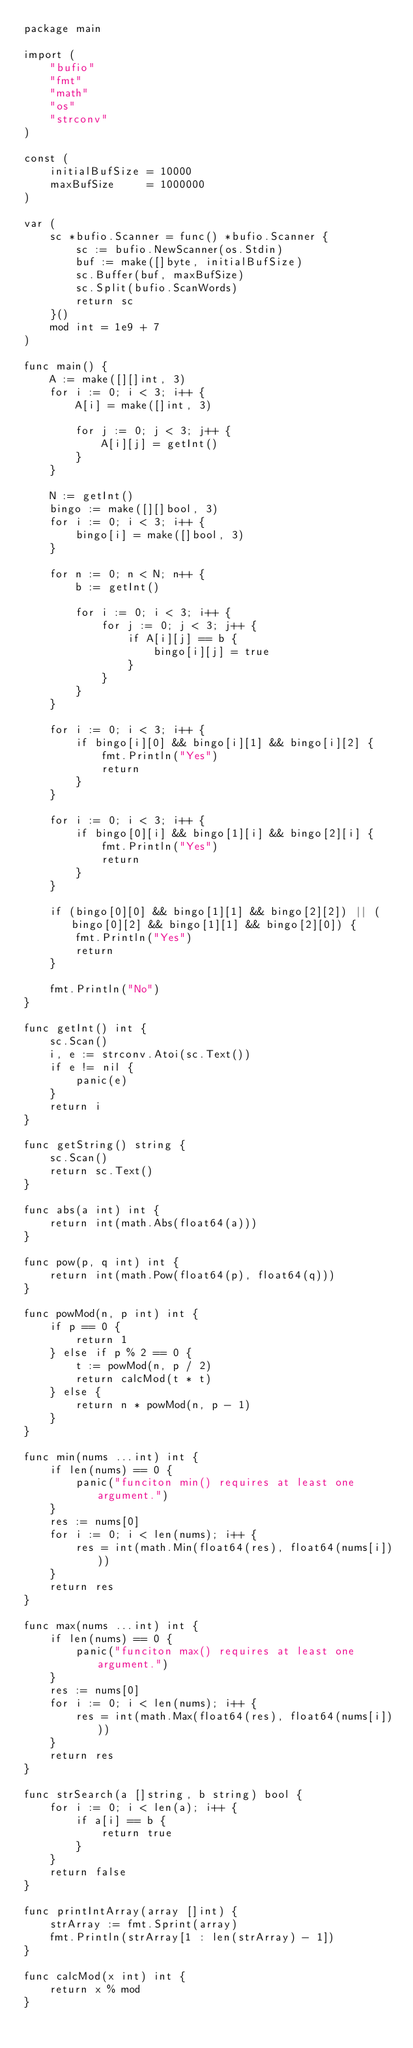<code> <loc_0><loc_0><loc_500><loc_500><_Go_>package main

import (
	"bufio"
	"fmt"
	"math"
	"os"
	"strconv"
)

const (
	initialBufSize = 10000
	maxBufSize     = 1000000
)

var (
	sc *bufio.Scanner = func() *bufio.Scanner {
		sc := bufio.NewScanner(os.Stdin)
		buf := make([]byte, initialBufSize)
		sc.Buffer(buf, maxBufSize)
		sc.Split(bufio.ScanWords)
		return sc
	}()
	mod int = 1e9 + 7
)

func main() {
	A := make([][]int, 3)
	for i := 0; i < 3; i++ {
		A[i] = make([]int, 3)

		for j := 0; j < 3; j++ {
			A[i][j] = getInt()
		}
	}

	N := getInt()
	bingo := make([][]bool, 3)
	for i := 0; i < 3; i++ {
		bingo[i] = make([]bool, 3)
	}

	for n := 0; n < N; n++ {
		b := getInt()

		for i := 0; i < 3; i++ {
			for j := 0; j < 3; j++ {
				if A[i][j] == b {
					bingo[i][j] = true
				}
			}
		}
	}

	for i := 0; i < 3; i++ {
		if bingo[i][0] && bingo[i][1] && bingo[i][2] {
			fmt.Println("Yes")
			return
		}
	}

	for i := 0; i < 3; i++ {
		if bingo[0][i] && bingo[1][i] && bingo[2][i] {
			fmt.Println("Yes")
			return
		}
	}

	if (bingo[0][0] && bingo[1][1] && bingo[2][2]) || (bingo[0][2] && bingo[1][1] && bingo[2][0]) {
		fmt.Println("Yes")
		return
	}

	fmt.Println("No")
}

func getInt() int {
	sc.Scan()
	i, e := strconv.Atoi(sc.Text())
	if e != nil {
		panic(e)
	}
	return i
}

func getString() string {
	sc.Scan()
	return sc.Text()
}

func abs(a int) int {
	return int(math.Abs(float64(a)))
}

func pow(p, q int) int {
	return int(math.Pow(float64(p), float64(q)))
}

func powMod(n, p int) int {
	if p == 0 {
		return 1
	} else if p % 2 == 0 {
		t := powMod(n, p / 2)
		return calcMod(t * t)
	} else {
		return n * powMod(n, p - 1)
	}
}

func min(nums ...int) int {
	if len(nums) == 0 {
		panic("funciton min() requires at least one argument.")
	}
	res := nums[0]
	for i := 0; i < len(nums); i++ {
		res = int(math.Min(float64(res), float64(nums[i])))
	}
	return res
}

func max(nums ...int) int {
	if len(nums) == 0 {
		panic("funciton max() requires at least one argument.")
	}
	res := nums[0]
	for i := 0; i < len(nums); i++ {
		res = int(math.Max(float64(res), float64(nums[i])))
	}
	return res
}

func strSearch(a []string, b string) bool {
	for i := 0; i < len(a); i++ {
		if a[i] == b {
			return true
		}
	}
	return false
}

func printIntArray(array []int) {
	strArray := fmt.Sprint(array)
	fmt.Println(strArray[1 : len(strArray) - 1])
}

func calcMod(x int) int {
	return x % mod
}
</code> 